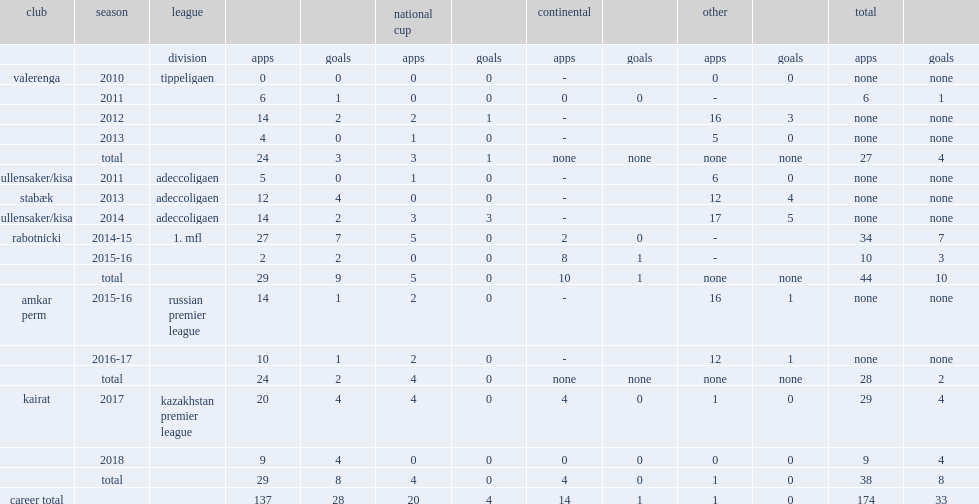How many matches did anene play for valerenga in the tippeligaen? 4.0. 